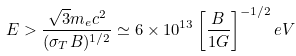<formula> <loc_0><loc_0><loc_500><loc_500>E > \frac { \sqrt { 3 } m _ { e } c ^ { 2 } } { ( \sigma _ { T } B ) ^ { 1 / 2 } } \simeq 6 \times 1 0 ^ { 1 3 } \left [ \frac { B } { 1 G } \right ] ^ { - 1 / 2 } e V</formula> 